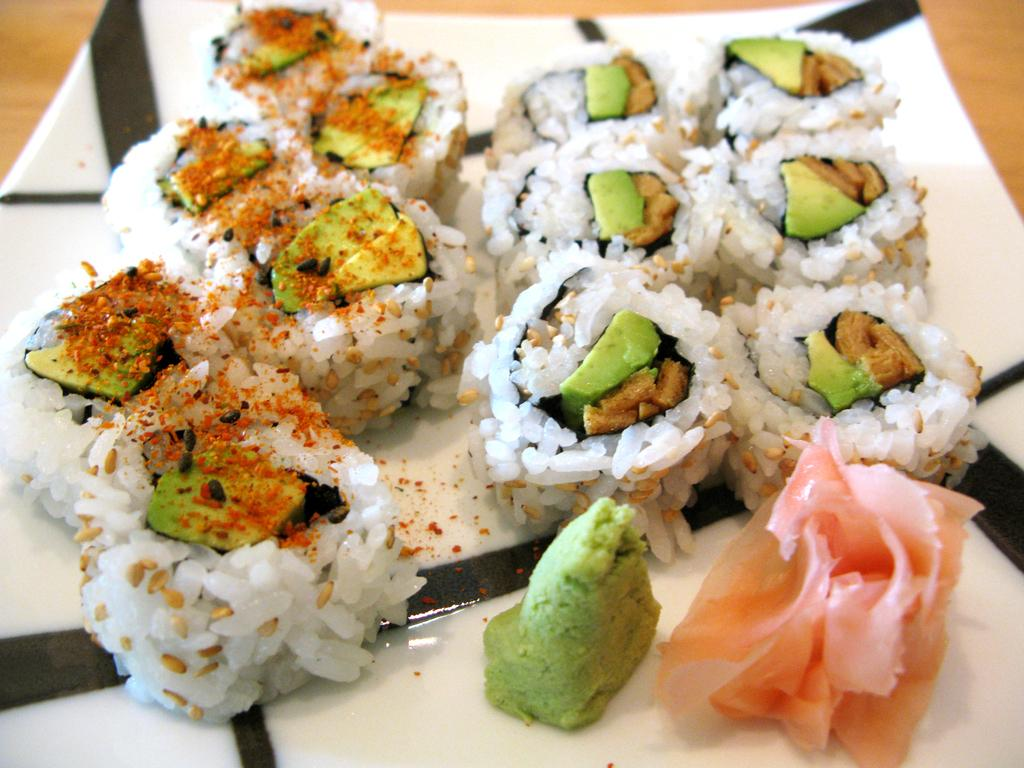What is present on the wooden surface in the image? There is a plate on the wooden surface in the image. What is the plate resting on? The plate is on a wooden surface. What can be found on the plate? There are food items on the plate. What type of gate can be seen in the image? There is no gate present in the image; it features a plate with food items on a wooden surface. 